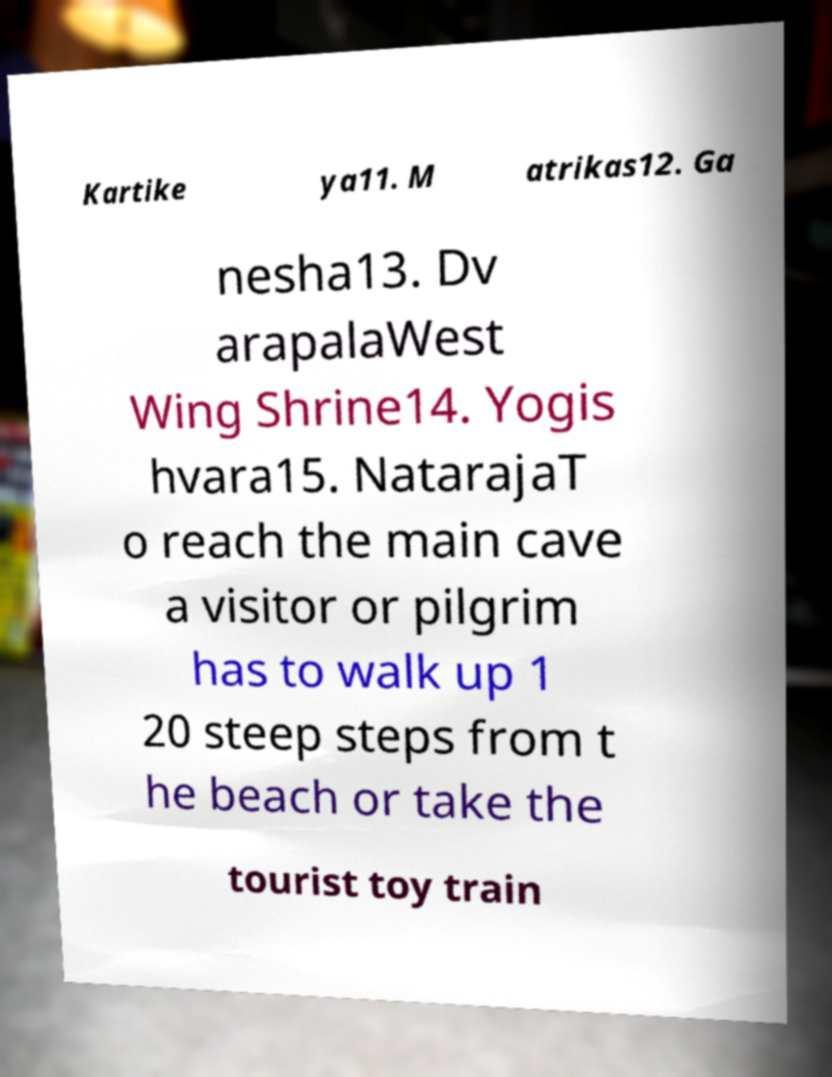Please read and relay the text visible in this image. What does it say? Kartike ya11. M atrikas12. Ga nesha13. Dv arapalaWest Wing Shrine14. Yogis hvara15. NatarajaT o reach the main cave a visitor or pilgrim has to walk up 1 20 steep steps from t he beach or take the tourist toy train 